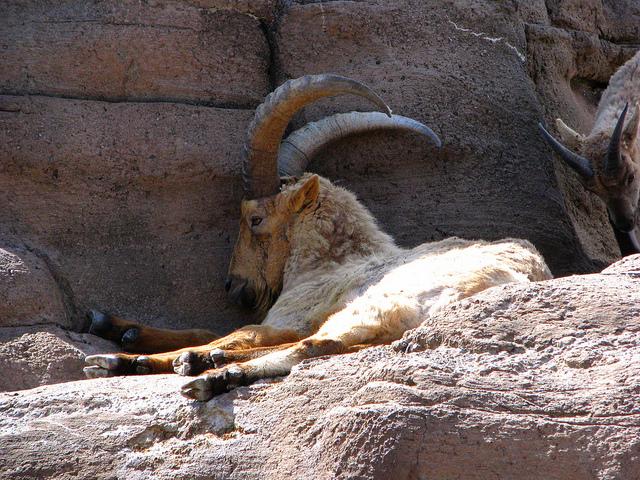How many animals are laying down?
Be succinct. 1. Is the animal standing?
Be succinct. No. Does the animal have horns?
Keep it brief. Yes. 